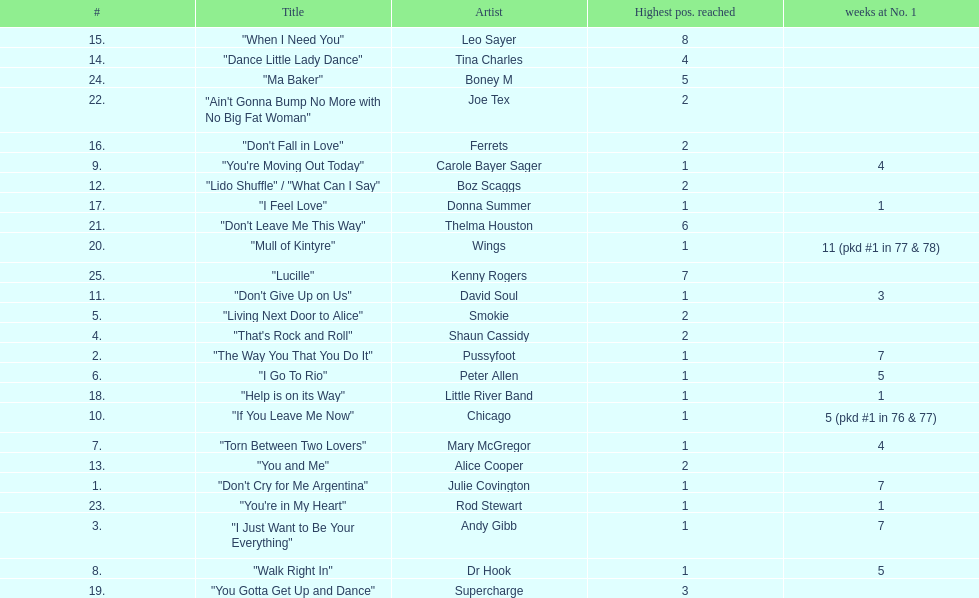Who had the most weeks at number one, according to the table? Wings. 